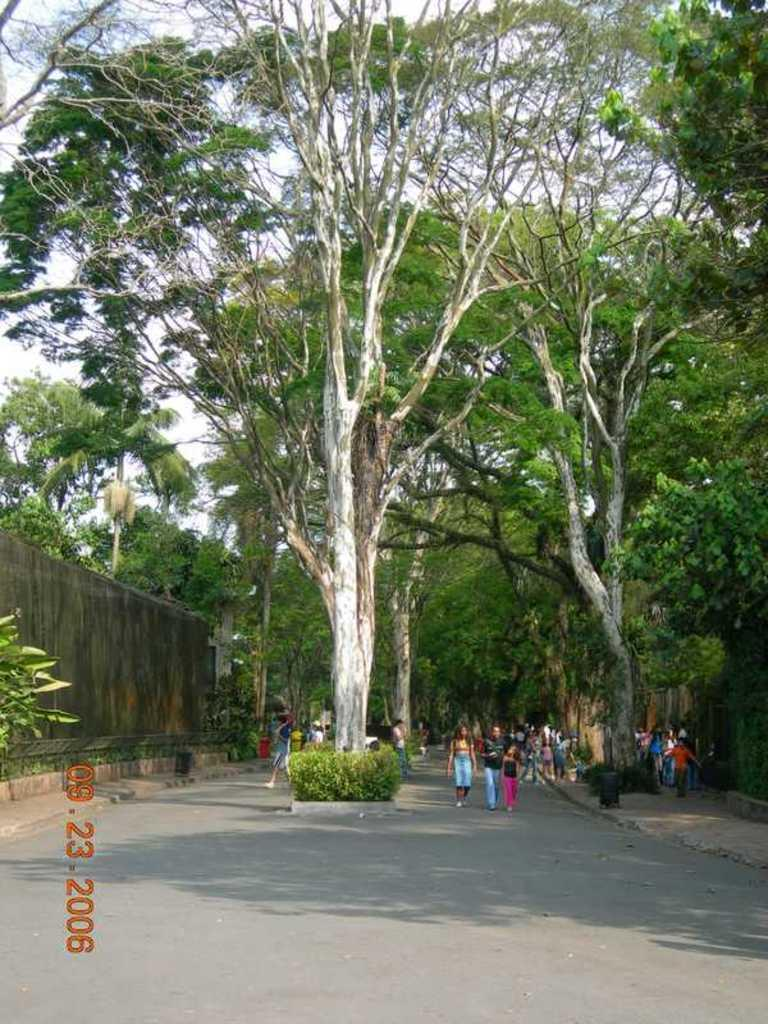What is located at the bottom of the image? There is a road at the bottom of the image. What are the people in the image doing? There are people walking on the road. What can be seen in the middle of the image? There are big trees in the middle of the image. What type of fiction is being read by the trees in the image? There are no books or fiction present in the image; it features a road, people walking, and big trees. What color is the zinc on the road in the image? There is no zinc present on the road in the image. 